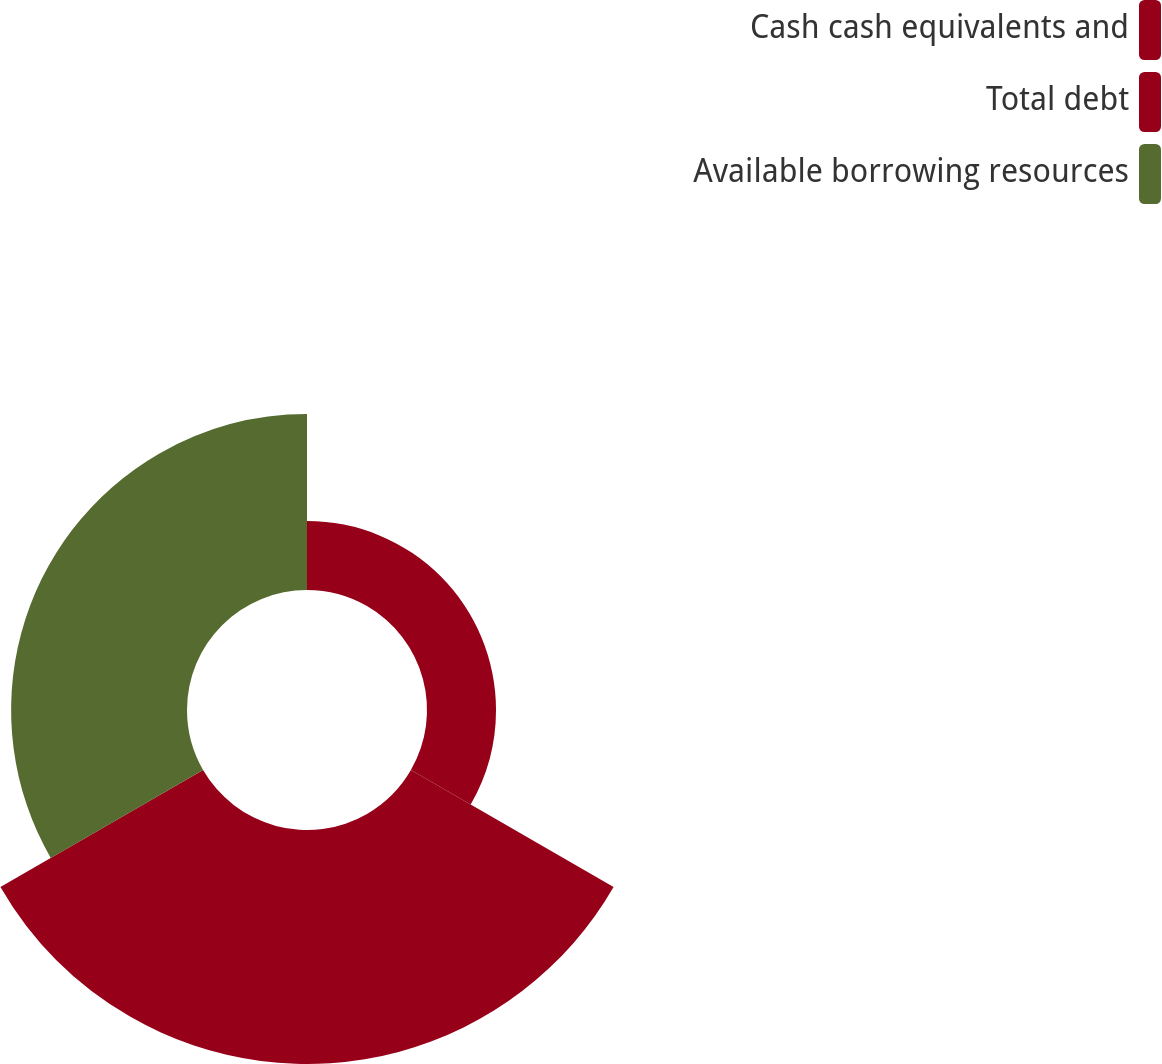Convert chart. <chart><loc_0><loc_0><loc_500><loc_500><pie_chart><fcel>Cash cash equivalents and<fcel>Total debt<fcel>Available borrowing resources<nl><fcel>14.41%<fcel>48.86%<fcel>36.73%<nl></chart> 